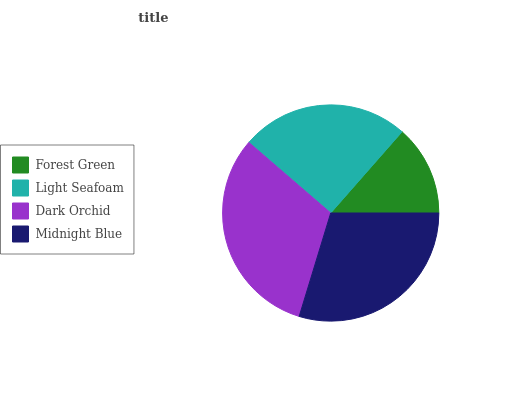Is Forest Green the minimum?
Answer yes or no. Yes. Is Dark Orchid the maximum?
Answer yes or no. Yes. Is Light Seafoam the minimum?
Answer yes or no. No. Is Light Seafoam the maximum?
Answer yes or no. No. Is Light Seafoam greater than Forest Green?
Answer yes or no. Yes. Is Forest Green less than Light Seafoam?
Answer yes or no. Yes. Is Forest Green greater than Light Seafoam?
Answer yes or no. No. Is Light Seafoam less than Forest Green?
Answer yes or no. No. Is Midnight Blue the high median?
Answer yes or no. Yes. Is Light Seafoam the low median?
Answer yes or no. Yes. Is Dark Orchid the high median?
Answer yes or no. No. Is Dark Orchid the low median?
Answer yes or no. No. 